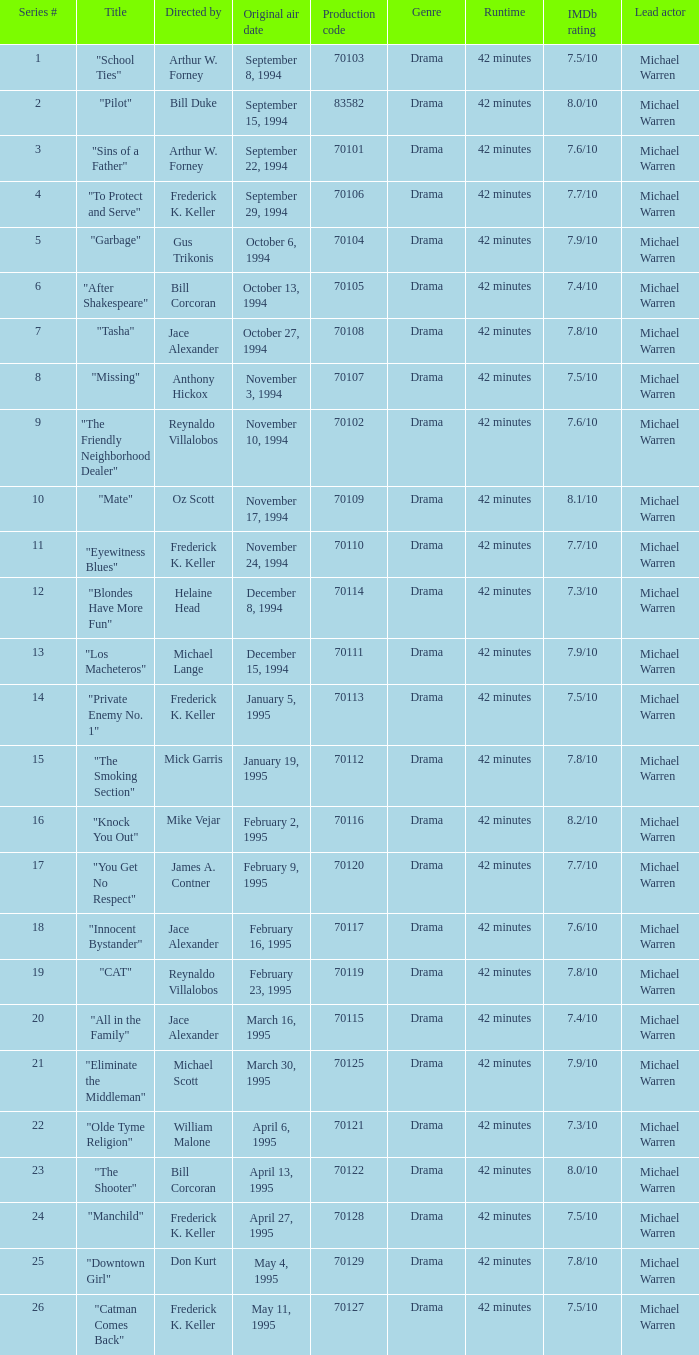What was the lowest production code value in series #10? 70109.0. 